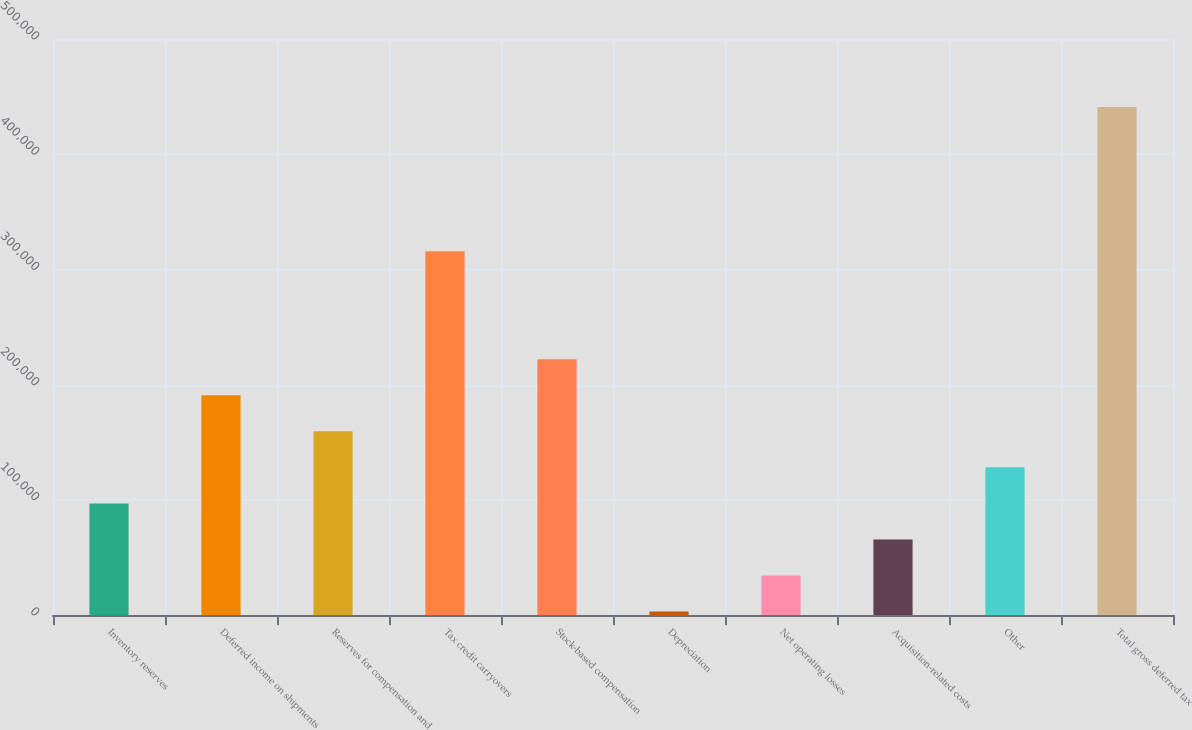Convert chart. <chart><loc_0><loc_0><loc_500><loc_500><bar_chart><fcel>Inventory reserves<fcel>Deferred income on shipments<fcel>Reserves for compensation and<fcel>Tax credit carryovers<fcel>Stock-based compensation<fcel>Depreciation<fcel>Net operating losses<fcel>Acquisition-related costs<fcel>Other<fcel>Total gross deferred tax<nl><fcel>96890.1<fcel>190702<fcel>159432<fcel>315785<fcel>221973<fcel>3078<fcel>34348.7<fcel>65619.4<fcel>128161<fcel>440868<nl></chart> 